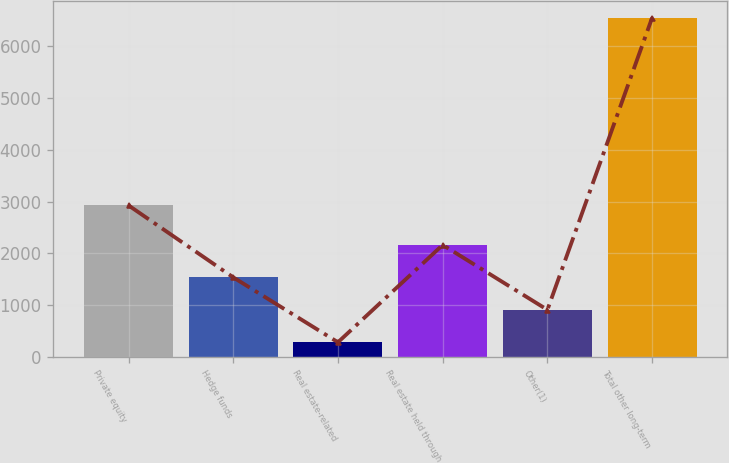Convert chart to OTSL. <chart><loc_0><loc_0><loc_500><loc_500><bar_chart><fcel>Private equity<fcel>Hedge funds<fcel>Real estate-related<fcel>Real estate held through<fcel>Other(1)<fcel>Total other long-term<nl><fcel>2927<fcel>1537.8<fcel>285<fcel>2164.2<fcel>911.4<fcel>6549<nl></chart> 